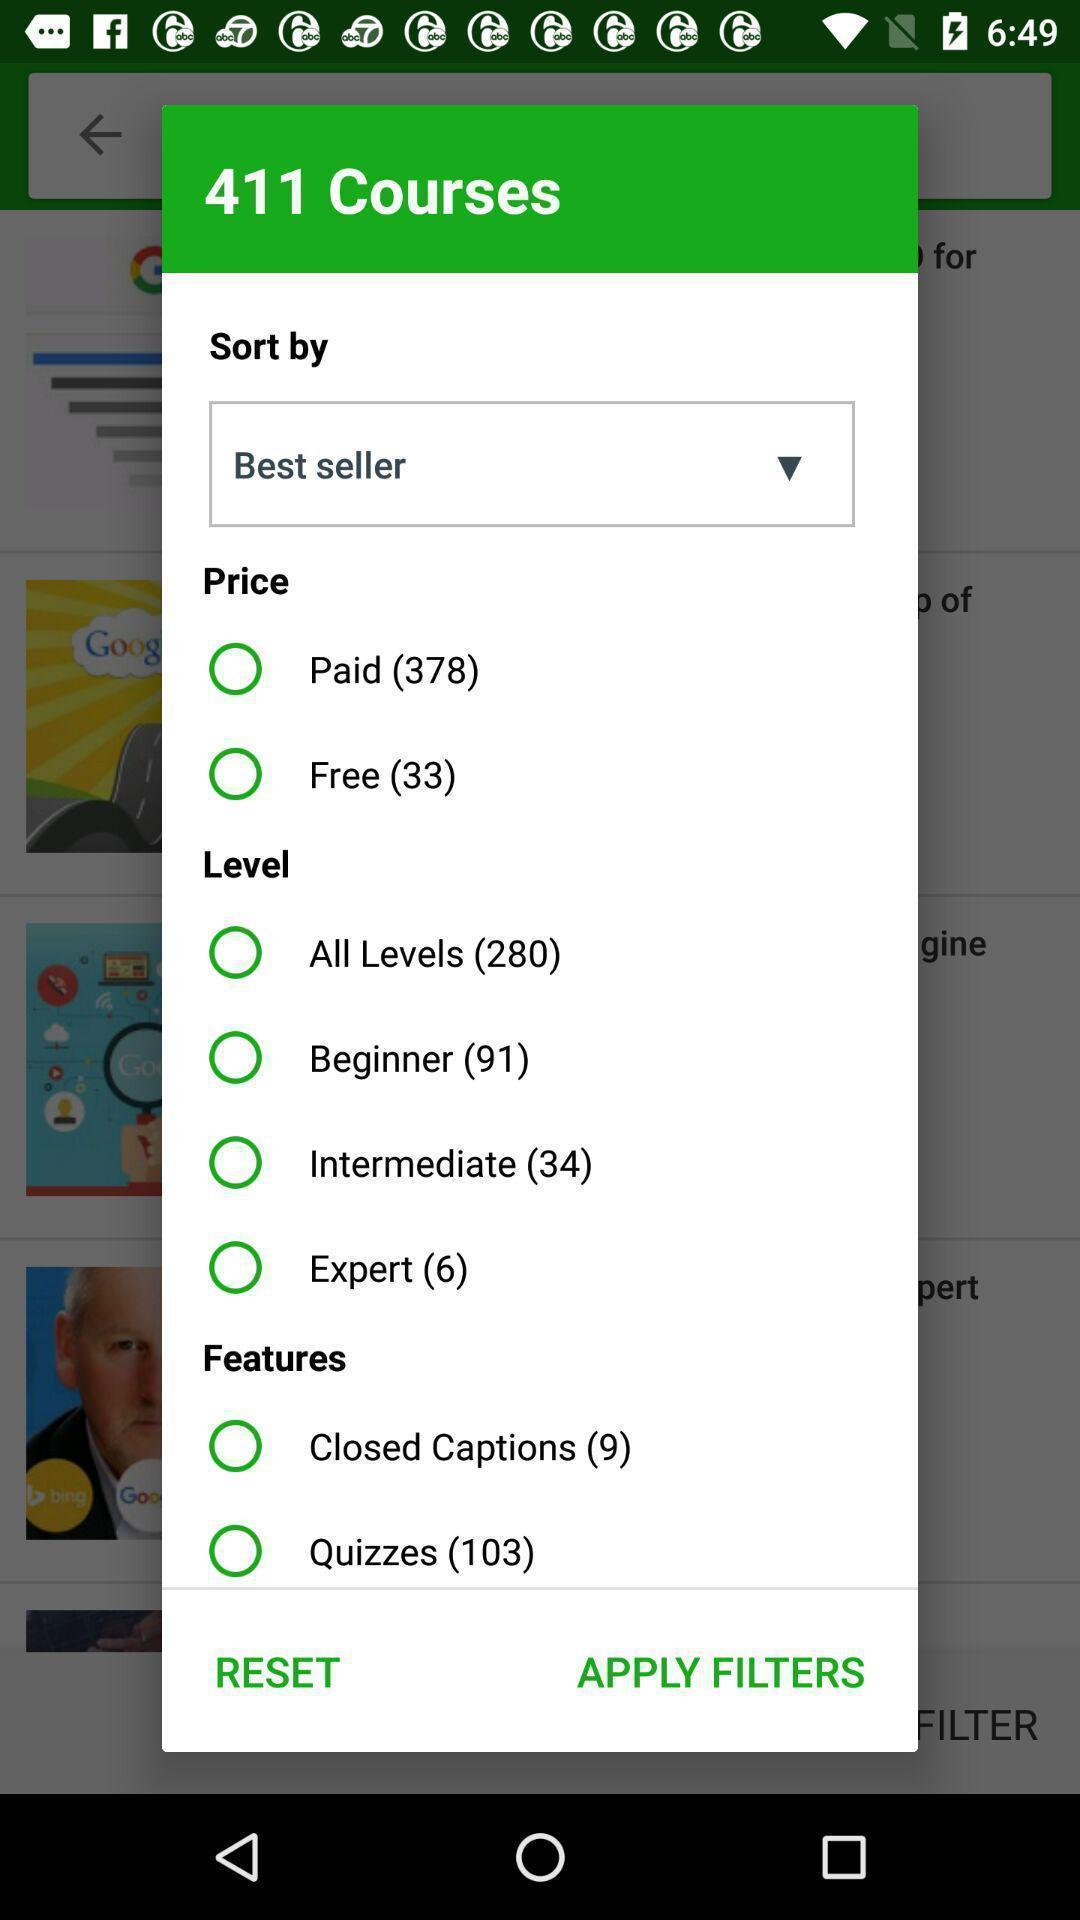Tell me about the visual elements in this screen capture. Popup page with details of all courses. 